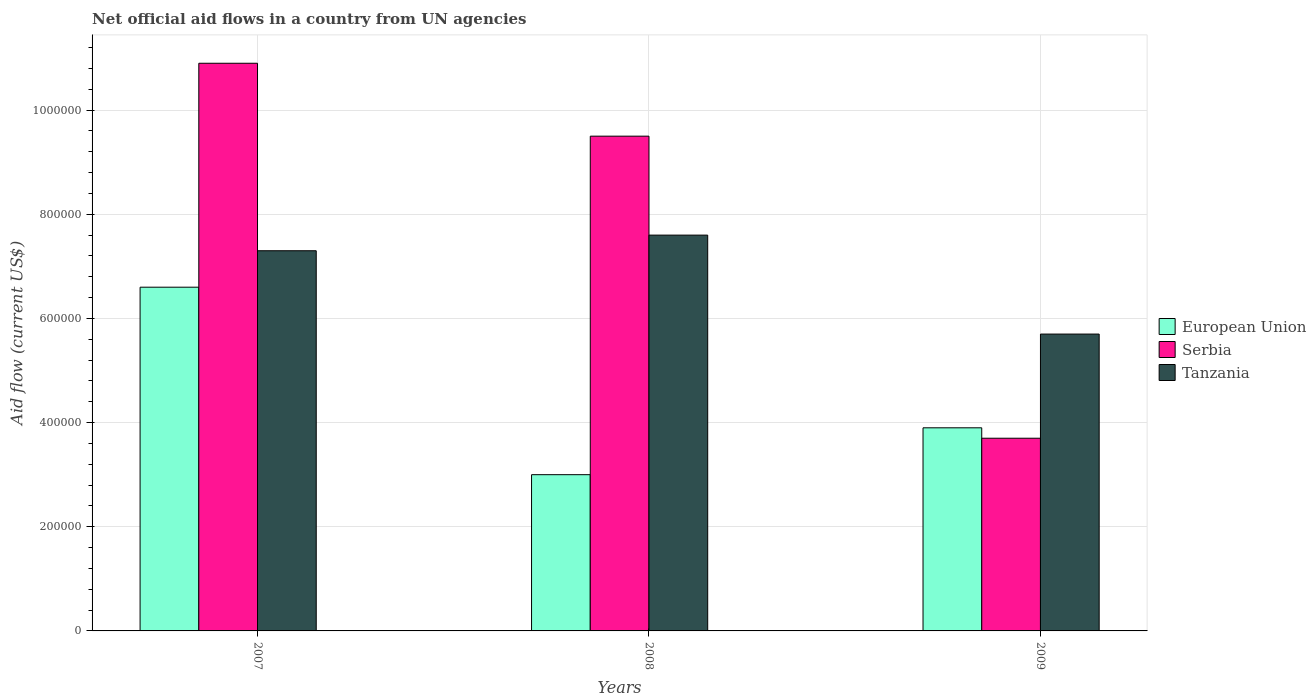Are the number of bars per tick equal to the number of legend labels?
Provide a succinct answer. Yes. How many bars are there on the 3rd tick from the left?
Provide a short and direct response. 3. What is the label of the 1st group of bars from the left?
Make the answer very short. 2007. What is the net official aid flow in Tanzania in 2008?
Make the answer very short. 7.60e+05. Across all years, what is the maximum net official aid flow in Serbia?
Offer a very short reply. 1.09e+06. Across all years, what is the minimum net official aid flow in Serbia?
Give a very brief answer. 3.70e+05. In which year was the net official aid flow in European Union minimum?
Your response must be concise. 2008. What is the total net official aid flow in Serbia in the graph?
Your answer should be very brief. 2.41e+06. What is the average net official aid flow in Serbia per year?
Offer a terse response. 8.03e+05. In the year 2008, what is the difference between the net official aid flow in Tanzania and net official aid flow in Serbia?
Provide a short and direct response. -1.90e+05. What is the ratio of the net official aid flow in European Union in 2007 to that in 2009?
Ensure brevity in your answer.  1.69. Is the difference between the net official aid flow in Tanzania in 2008 and 2009 greater than the difference between the net official aid flow in Serbia in 2008 and 2009?
Offer a very short reply. No. In how many years, is the net official aid flow in Tanzania greater than the average net official aid flow in Tanzania taken over all years?
Make the answer very short. 2. Is the sum of the net official aid flow in European Union in 2007 and 2009 greater than the maximum net official aid flow in Tanzania across all years?
Provide a succinct answer. Yes. What does the 2nd bar from the left in 2008 represents?
Make the answer very short. Serbia. What does the 1st bar from the right in 2007 represents?
Your response must be concise. Tanzania. How many bars are there?
Make the answer very short. 9. Are all the bars in the graph horizontal?
Offer a very short reply. No. What is the difference between two consecutive major ticks on the Y-axis?
Your answer should be compact. 2.00e+05. Does the graph contain any zero values?
Your answer should be very brief. No. Does the graph contain grids?
Your answer should be very brief. Yes. Where does the legend appear in the graph?
Ensure brevity in your answer.  Center right. How many legend labels are there?
Your answer should be very brief. 3. How are the legend labels stacked?
Offer a terse response. Vertical. What is the title of the graph?
Your answer should be very brief. Net official aid flows in a country from UN agencies. What is the Aid flow (current US$) of European Union in 2007?
Make the answer very short. 6.60e+05. What is the Aid flow (current US$) of Serbia in 2007?
Provide a succinct answer. 1.09e+06. What is the Aid flow (current US$) of Tanzania in 2007?
Offer a very short reply. 7.30e+05. What is the Aid flow (current US$) of European Union in 2008?
Give a very brief answer. 3.00e+05. What is the Aid flow (current US$) of Serbia in 2008?
Keep it short and to the point. 9.50e+05. What is the Aid flow (current US$) of Tanzania in 2008?
Ensure brevity in your answer.  7.60e+05. What is the Aid flow (current US$) in Tanzania in 2009?
Provide a short and direct response. 5.70e+05. Across all years, what is the maximum Aid flow (current US$) of European Union?
Provide a succinct answer. 6.60e+05. Across all years, what is the maximum Aid flow (current US$) in Serbia?
Give a very brief answer. 1.09e+06. Across all years, what is the maximum Aid flow (current US$) of Tanzania?
Give a very brief answer. 7.60e+05. Across all years, what is the minimum Aid flow (current US$) of European Union?
Give a very brief answer. 3.00e+05. Across all years, what is the minimum Aid flow (current US$) of Serbia?
Make the answer very short. 3.70e+05. Across all years, what is the minimum Aid flow (current US$) in Tanzania?
Offer a terse response. 5.70e+05. What is the total Aid flow (current US$) in European Union in the graph?
Provide a succinct answer. 1.35e+06. What is the total Aid flow (current US$) of Serbia in the graph?
Make the answer very short. 2.41e+06. What is the total Aid flow (current US$) in Tanzania in the graph?
Your response must be concise. 2.06e+06. What is the difference between the Aid flow (current US$) in Serbia in 2007 and that in 2009?
Offer a very short reply. 7.20e+05. What is the difference between the Aid flow (current US$) in European Union in 2008 and that in 2009?
Offer a terse response. -9.00e+04. What is the difference between the Aid flow (current US$) in Serbia in 2008 and that in 2009?
Offer a terse response. 5.80e+05. What is the difference between the Aid flow (current US$) in Tanzania in 2008 and that in 2009?
Give a very brief answer. 1.90e+05. What is the difference between the Aid flow (current US$) of European Union in 2007 and the Aid flow (current US$) of Tanzania in 2008?
Ensure brevity in your answer.  -1.00e+05. What is the difference between the Aid flow (current US$) in Serbia in 2007 and the Aid flow (current US$) in Tanzania in 2008?
Offer a very short reply. 3.30e+05. What is the difference between the Aid flow (current US$) of European Union in 2007 and the Aid flow (current US$) of Serbia in 2009?
Offer a very short reply. 2.90e+05. What is the difference between the Aid flow (current US$) in European Union in 2007 and the Aid flow (current US$) in Tanzania in 2009?
Offer a terse response. 9.00e+04. What is the difference between the Aid flow (current US$) in Serbia in 2007 and the Aid flow (current US$) in Tanzania in 2009?
Provide a succinct answer. 5.20e+05. What is the difference between the Aid flow (current US$) of Serbia in 2008 and the Aid flow (current US$) of Tanzania in 2009?
Keep it short and to the point. 3.80e+05. What is the average Aid flow (current US$) in European Union per year?
Ensure brevity in your answer.  4.50e+05. What is the average Aid flow (current US$) of Serbia per year?
Make the answer very short. 8.03e+05. What is the average Aid flow (current US$) of Tanzania per year?
Offer a very short reply. 6.87e+05. In the year 2007, what is the difference between the Aid flow (current US$) of European Union and Aid flow (current US$) of Serbia?
Ensure brevity in your answer.  -4.30e+05. In the year 2007, what is the difference between the Aid flow (current US$) of European Union and Aid flow (current US$) of Tanzania?
Keep it short and to the point. -7.00e+04. In the year 2008, what is the difference between the Aid flow (current US$) of European Union and Aid flow (current US$) of Serbia?
Keep it short and to the point. -6.50e+05. In the year 2008, what is the difference between the Aid flow (current US$) in European Union and Aid flow (current US$) in Tanzania?
Provide a succinct answer. -4.60e+05. In the year 2008, what is the difference between the Aid flow (current US$) of Serbia and Aid flow (current US$) of Tanzania?
Ensure brevity in your answer.  1.90e+05. In the year 2009, what is the difference between the Aid flow (current US$) in Serbia and Aid flow (current US$) in Tanzania?
Your response must be concise. -2.00e+05. What is the ratio of the Aid flow (current US$) in European Union in 2007 to that in 2008?
Provide a succinct answer. 2.2. What is the ratio of the Aid flow (current US$) of Serbia in 2007 to that in 2008?
Your answer should be very brief. 1.15. What is the ratio of the Aid flow (current US$) of Tanzania in 2007 to that in 2008?
Provide a short and direct response. 0.96. What is the ratio of the Aid flow (current US$) of European Union in 2007 to that in 2009?
Offer a terse response. 1.69. What is the ratio of the Aid flow (current US$) in Serbia in 2007 to that in 2009?
Offer a terse response. 2.95. What is the ratio of the Aid flow (current US$) of Tanzania in 2007 to that in 2009?
Give a very brief answer. 1.28. What is the ratio of the Aid flow (current US$) in European Union in 2008 to that in 2009?
Your answer should be compact. 0.77. What is the ratio of the Aid flow (current US$) in Serbia in 2008 to that in 2009?
Offer a very short reply. 2.57. What is the difference between the highest and the second highest Aid flow (current US$) in European Union?
Ensure brevity in your answer.  2.70e+05. What is the difference between the highest and the second highest Aid flow (current US$) of Serbia?
Ensure brevity in your answer.  1.40e+05. What is the difference between the highest and the second highest Aid flow (current US$) in Tanzania?
Give a very brief answer. 3.00e+04. What is the difference between the highest and the lowest Aid flow (current US$) of European Union?
Provide a succinct answer. 3.60e+05. What is the difference between the highest and the lowest Aid flow (current US$) in Serbia?
Provide a short and direct response. 7.20e+05. What is the difference between the highest and the lowest Aid flow (current US$) in Tanzania?
Keep it short and to the point. 1.90e+05. 